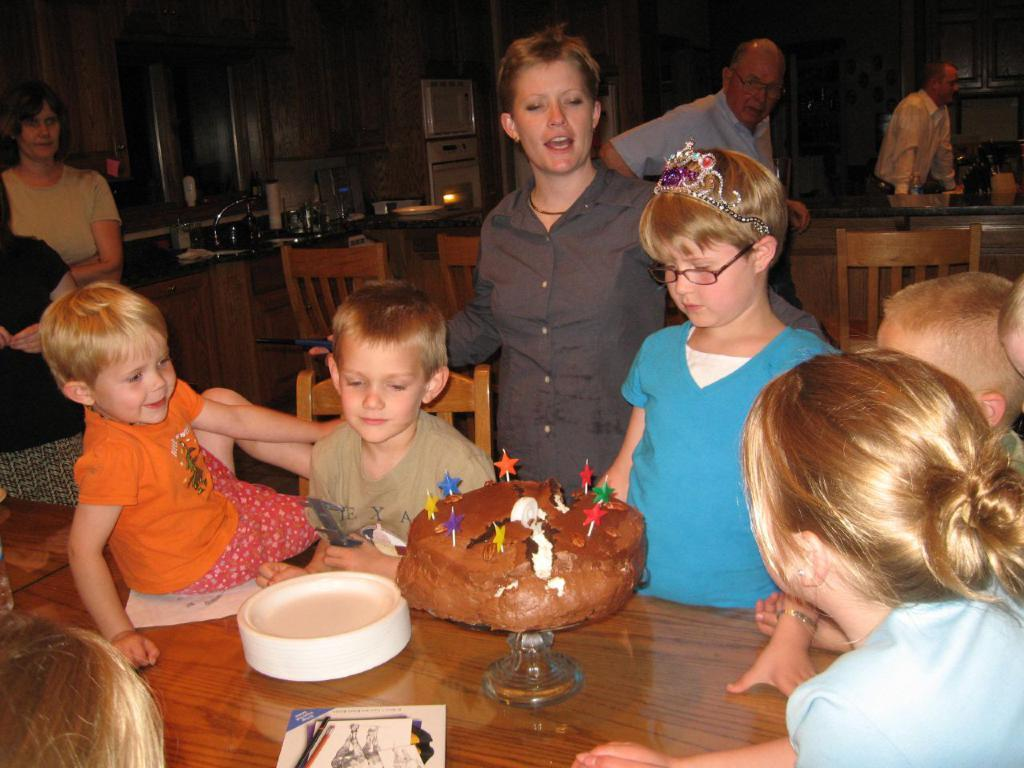How many people are in the image? There is a group of people in the image, but the exact number cannot be determined from the provided facts. What is on the table in the image? There is a cake on the table in the image. What type of furniture is present in the image? There are chairs in the image. What other objects can be seen in the image? There are other objects in the image, but their specific nature cannot be determined from the provided facts. What can be seen in the background of the image? There is a wooden wall in the background of the image. Is there a volcano erupting in the background of the image? No, there is no volcano present in the image. What type of wrench is being used by the person in the image? There is no wrench visible in the image. 